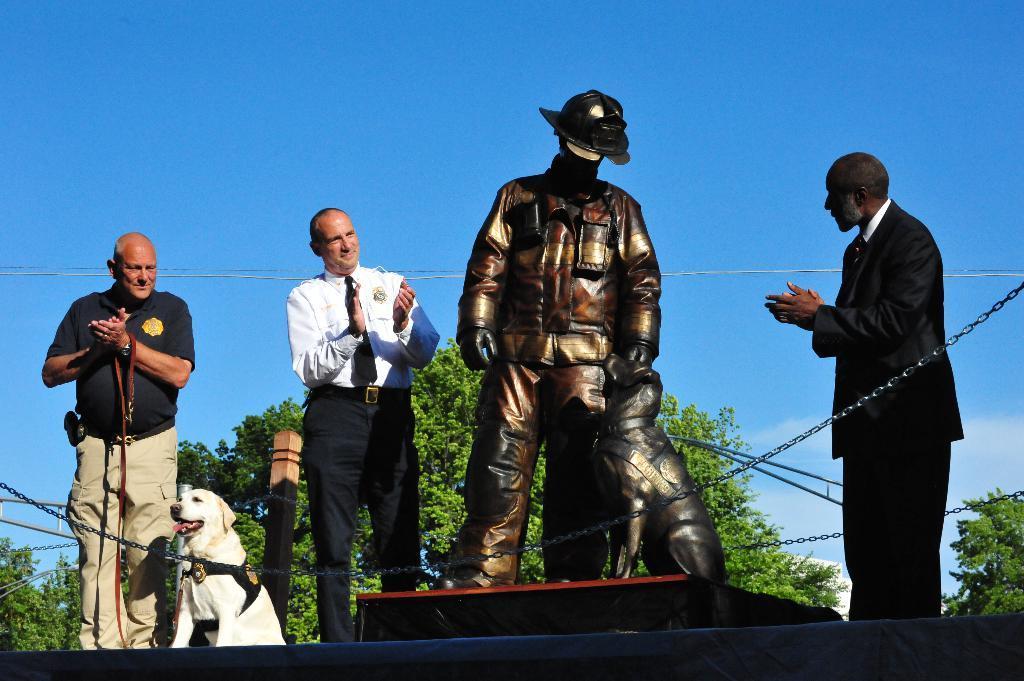Describe this image in one or two sentences. In this image I can see number of people and a dog. I can also see a sculpture of a man and a dog. 